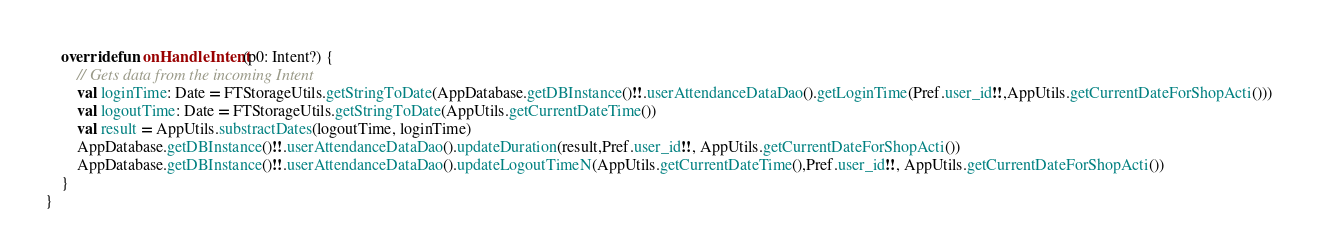<code> <loc_0><loc_0><loc_500><loc_500><_Kotlin_>    override fun onHandleIntent(p0: Intent?) {
        // Gets data from the incoming Intent
        val loginTime: Date = FTStorageUtils.getStringToDate(AppDatabase.getDBInstance()!!.userAttendanceDataDao().getLoginTime(Pref.user_id!!,AppUtils.getCurrentDateForShopActi()))
        val logoutTime: Date = FTStorageUtils.getStringToDate(AppUtils.getCurrentDateTime())
        val result = AppUtils.substractDates(logoutTime, loginTime)
        AppDatabase.getDBInstance()!!.userAttendanceDataDao().updateDuration(result,Pref.user_id!!, AppUtils.getCurrentDateForShopActi())
        AppDatabase.getDBInstance()!!.userAttendanceDataDao().updateLogoutTimeN(AppUtils.getCurrentDateTime(),Pref.user_id!!, AppUtils.getCurrentDateForShopActi())
    }
}</code> 